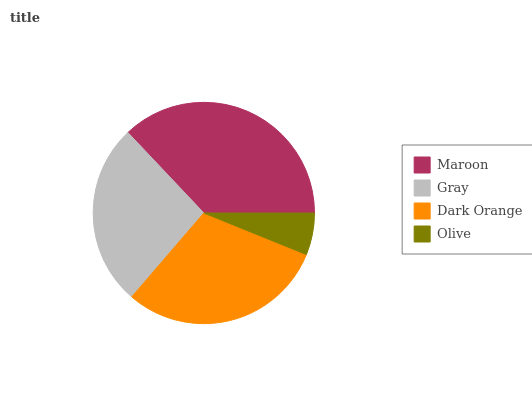Is Olive the minimum?
Answer yes or no. Yes. Is Maroon the maximum?
Answer yes or no. Yes. Is Gray the minimum?
Answer yes or no. No. Is Gray the maximum?
Answer yes or no. No. Is Maroon greater than Gray?
Answer yes or no. Yes. Is Gray less than Maroon?
Answer yes or no. Yes. Is Gray greater than Maroon?
Answer yes or no. No. Is Maroon less than Gray?
Answer yes or no. No. Is Dark Orange the high median?
Answer yes or no. Yes. Is Gray the low median?
Answer yes or no. Yes. Is Olive the high median?
Answer yes or no. No. Is Dark Orange the low median?
Answer yes or no. No. 